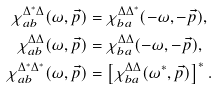Convert formula to latex. <formula><loc_0><loc_0><loc_500><loc_500>\chi ^ { \Delta ^ { * } \Delta } _ { a b } ( \omega , \vec { p } ) & = \chi ^ { \Delta \Delta ^ { * } } _ { b a } ( - \omega , - \vec { p } ) , \\ \chi ^ { \Delta \Delta } _ { a b } ( \omega , \vec { p } ) & = \chi ^ { \Delta \Delta } _ { b a } ( - \omega , - \vec { p } ) , \\ \chi ^ { \Delta ^ { * } \Delta ^ { * } } _ { a b } ( \omega , \vec { p } ) & = \left [ \chi ^ { \Delta \Delta } _ { b a } ( \omega ^ { * } , \vec { p } ) \right ] ^ { * } .</formula> 